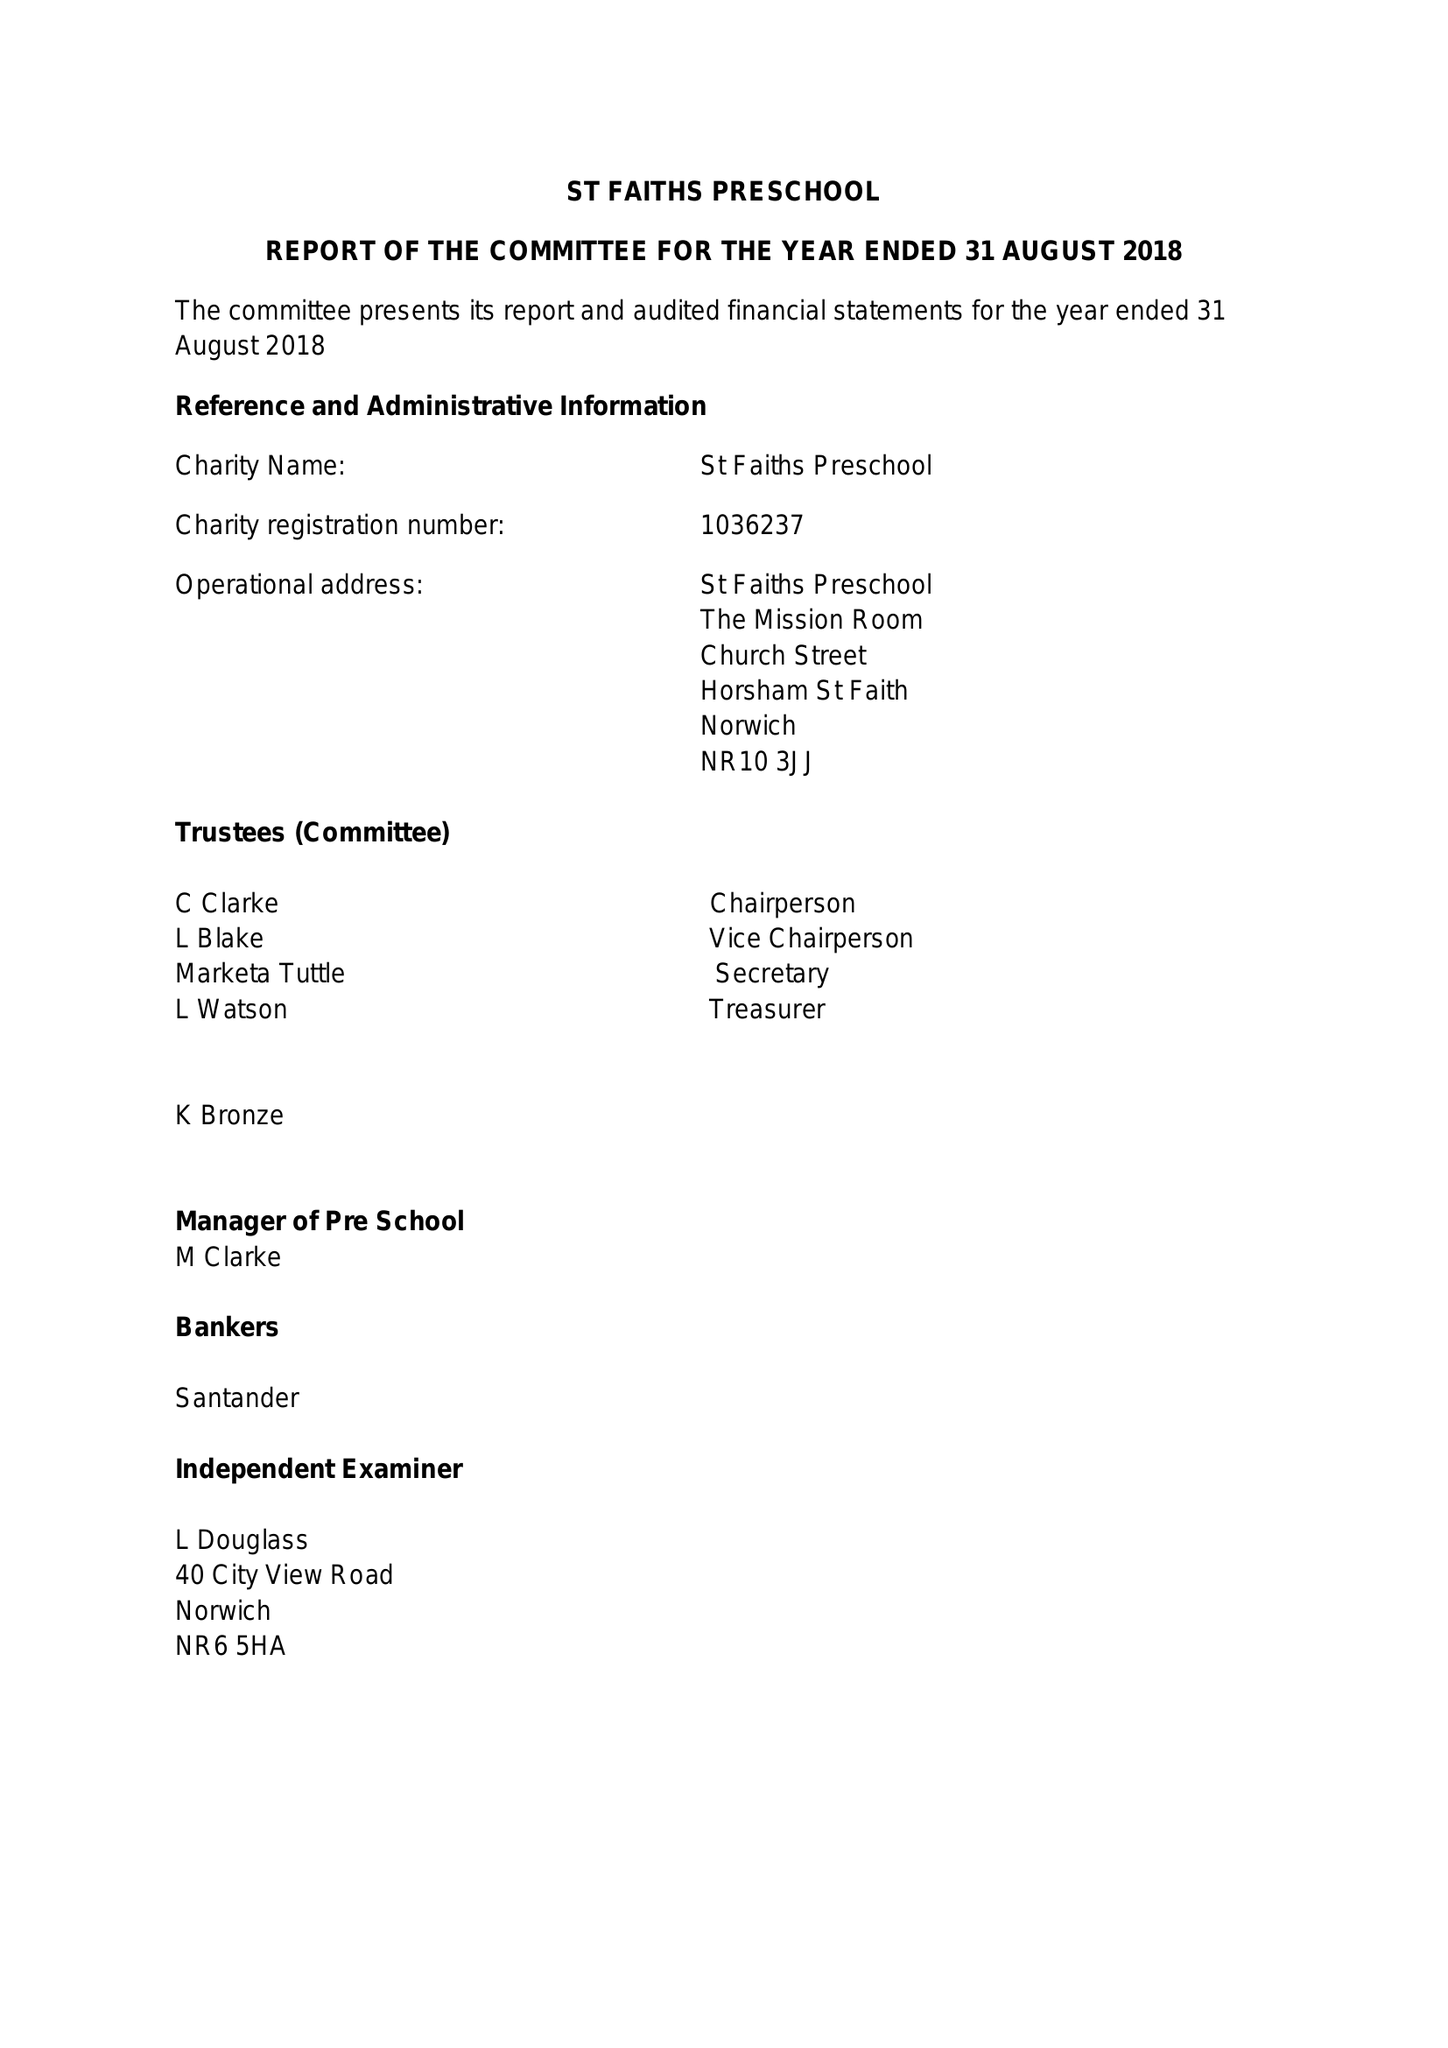What is the value for the charity_name?
Answer the question using a single word or phrase. St Faith's Under Fives 